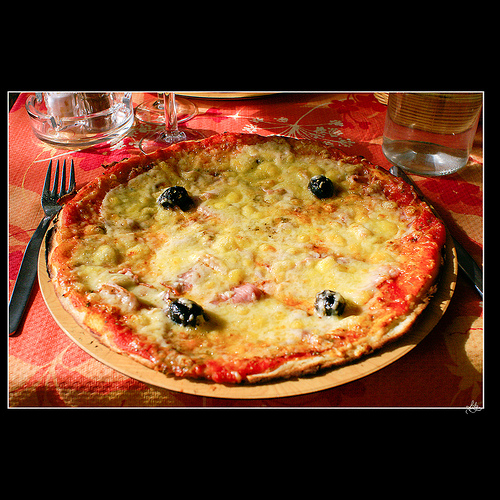<image>
Can you confirm if the fork is on the plate? No. The fork is not positioned on the plate. They may be near each other, but the fork is not supported by or resting on top of the plate. Is the pizza in the table? No. The pizza is not contained within the table. These objects have a different spatial relationship. 